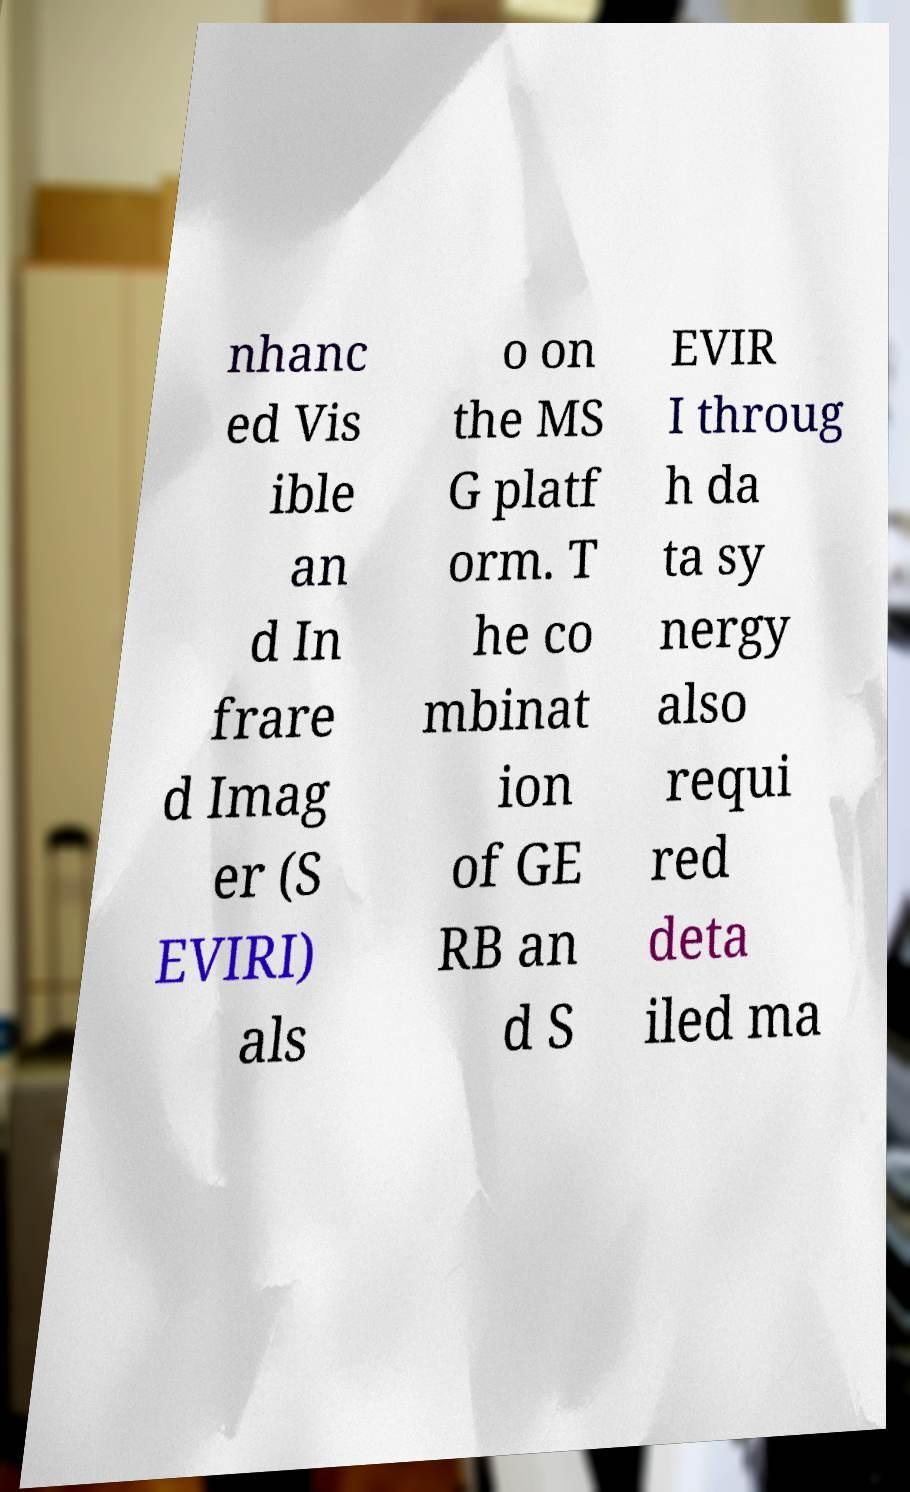Can you read and provide the text displayed in the image?This photo seems to have some interesting text. Can you extract and type it out for me? nhanc ed Vis ible an d In frare d Imag er (S EVIRI) als o on the MS G platf orm. T he co mbinat ion of GE RB an d S EVIR I throug h da ta sy nergy also requi red deta iled ma 